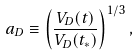<formula> <loc_0><loc_0><loc_500><loc_500>a _ { D } \equiv \left ( \frac { V _ { D } ( t ) } { V _ { D } ( t _ { * } ) } \right ) ^ { 1 / 3 } ,</formula> 